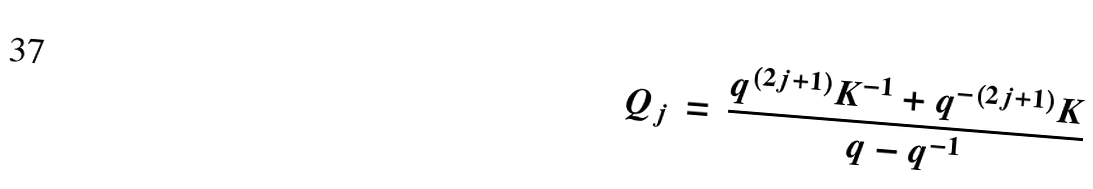<formula> <loc_0><loc_0><loc_500><loc_500>Q _ { j } \, = \, \frac { q ^ { ( 2 j + 1 ) } K ^ { - 1 } + q ^ { - ( 2 j + 1 ) } K } { q - q ^ { - 1 } }</formula> 